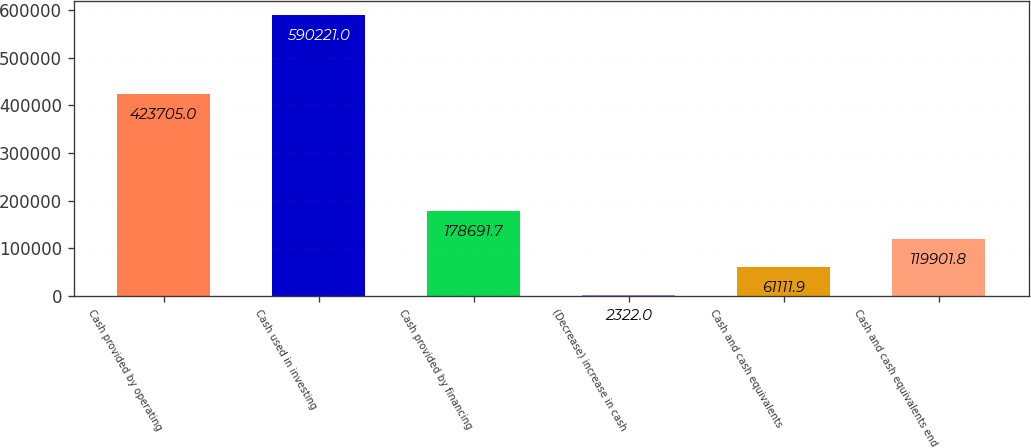Convert chart. <chart><loc_0><loc_0><loc_500><loc_500><bar_chart><fcel>Cash provided by operating<fcel>Cash used in investing<fcel>Cash provided by financing<fcel>(Decrease) increase in cash<fcel>Cash and cash equivalents<fcel>Cash and cash equivalents end<nl><fcel>423705<fcel>590221<fcel>178692<fcel>2322<fcel>61111.9<fcel>119902<nl></chart> 